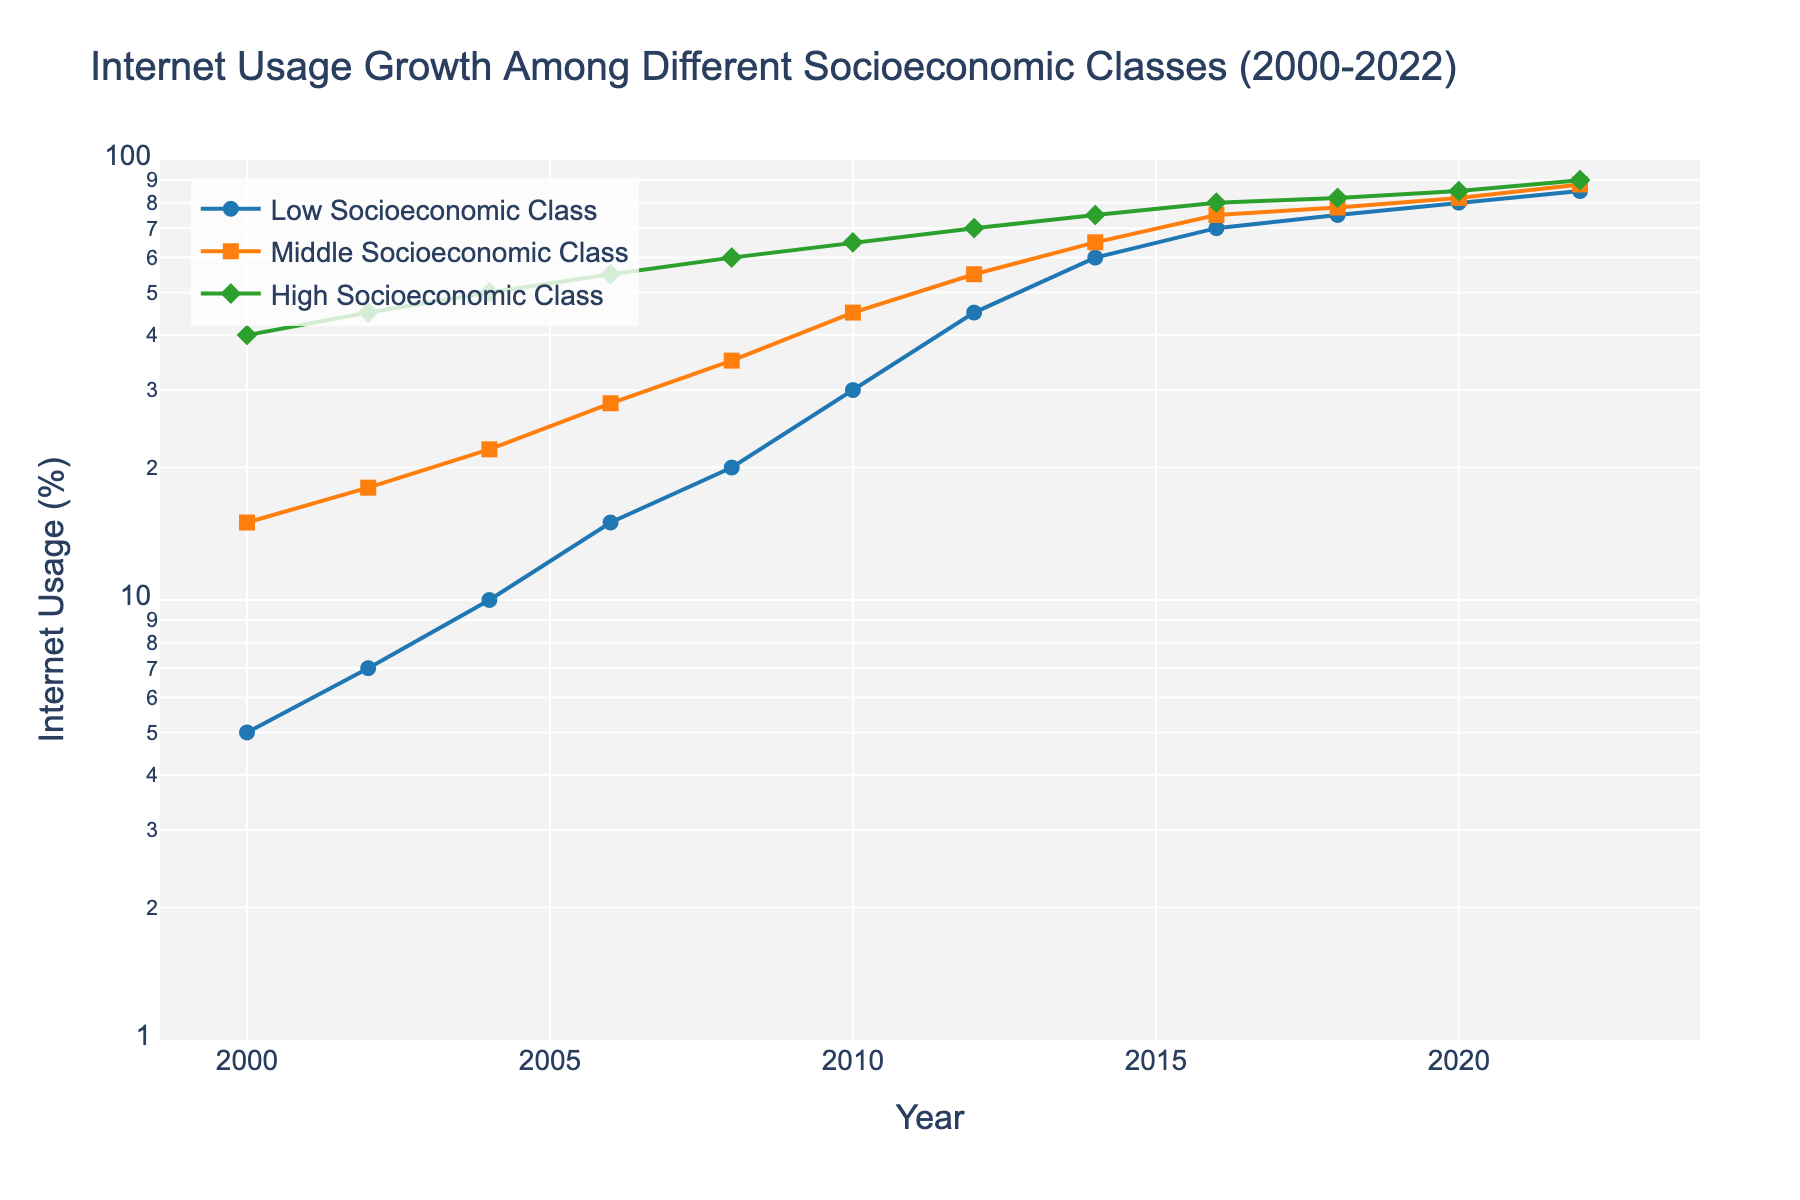What is the title of the figure? The title of the figure is located at the top and it provides an overview of what the figure represents. Here, it specifies the topic and the timeframe.
Answer: Internet Usage Growth Among Different Socioeconomic Classes (2000-2022) What is the internet usage percentage for the low socioeconomic class in 2000? Locate the point for the low socioeconomic class in the year 2000 on the x-axis and follow it up to intersect the line. The y-axis value corresponding to this point gives the percentage.
Answer: 5% Which socioeconomic class experienced the highest internet usage growth by 2022? Examine the endpoints of each socioeconomic class line at the year 2022. The one with the highest value on the y-axis indicates the class with the highest internet usage.
Answer: High Socioeconomic Class By how much did the internet usage percentage for the middle socioeconomic class increase from 2000 to 2010? Locate the internet usage values for the middle socioeconomic class in 2000 and 2010. Calculate the difference between these two values.
Answer: 30% What is the difference in internet usage percentage between the high and low socioeconomic classes in 2004? Identify the internet usage percentages for the high and low socioeconomic classes in 2004. Subtract the low class percentage from the high class percentage to get the difference.
Answer: 40% In which year did the low socioeconomic class surpass 50% internet usage? Follow the line representing the low socioeconomic class and identify the year at which the value exceeds 50% on the y-axis.
Answer: 2014 How did the internet usage percentage change for the high socioeconomic class from 2016 to 2020? Locate the values for the high socioeconomic class in 2016 and 2020, and calculate the difference between these two percentages.
Answer: 5% Which class had the closest internet usage percentage in 2018, and what was the value? Compare the internet usage percentages of each class in 2018 and find the two with the closest values.
Answer: Middle and high socioeconomic classes, with values of 78% and 82%, respectively What trend can be observed for the internet usage in the low socioeconomic class over the years? Observe the points and their general direction on the line representing the low socioeconomic class over the period from 2000 to 2022. The trend shows whether the percentage is increasing, decreasing, or staying constant.
Answer: Increasing When did the middle socioeconomic class first reach 65% internet usage? Identify the data point where the line representing the middle socioeconomic class intersects the 65% mark on the y-axis. Determine the corresponding year on the x-axis.
Answer: 2014 